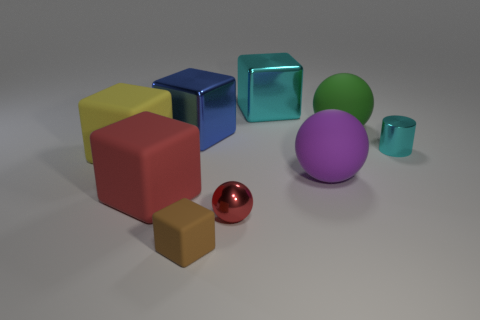Add 1 big rubber balls. How many objects exist? 10 Subtract all big spheres. How many spheres are left? 1 Subtract all cylinders. How many objects are left? 8 Subtract 1 balls. How many balls are left? 2 Add 5 shiny things. How many shiny things exist? 9 Subtract all brown cubes. How many cubes are left? 4 Subtract 1 cyan cubes. How many objects are left? 8 Subtract all purple cubes. Subtract all red balls. How many cubes are left? 5 Subtract all yellow rubber things. Subtract all large green matte things. How many objects are left? 7 Add 6 large purple rubber objects. How many large purple rubber objects are left? 7 